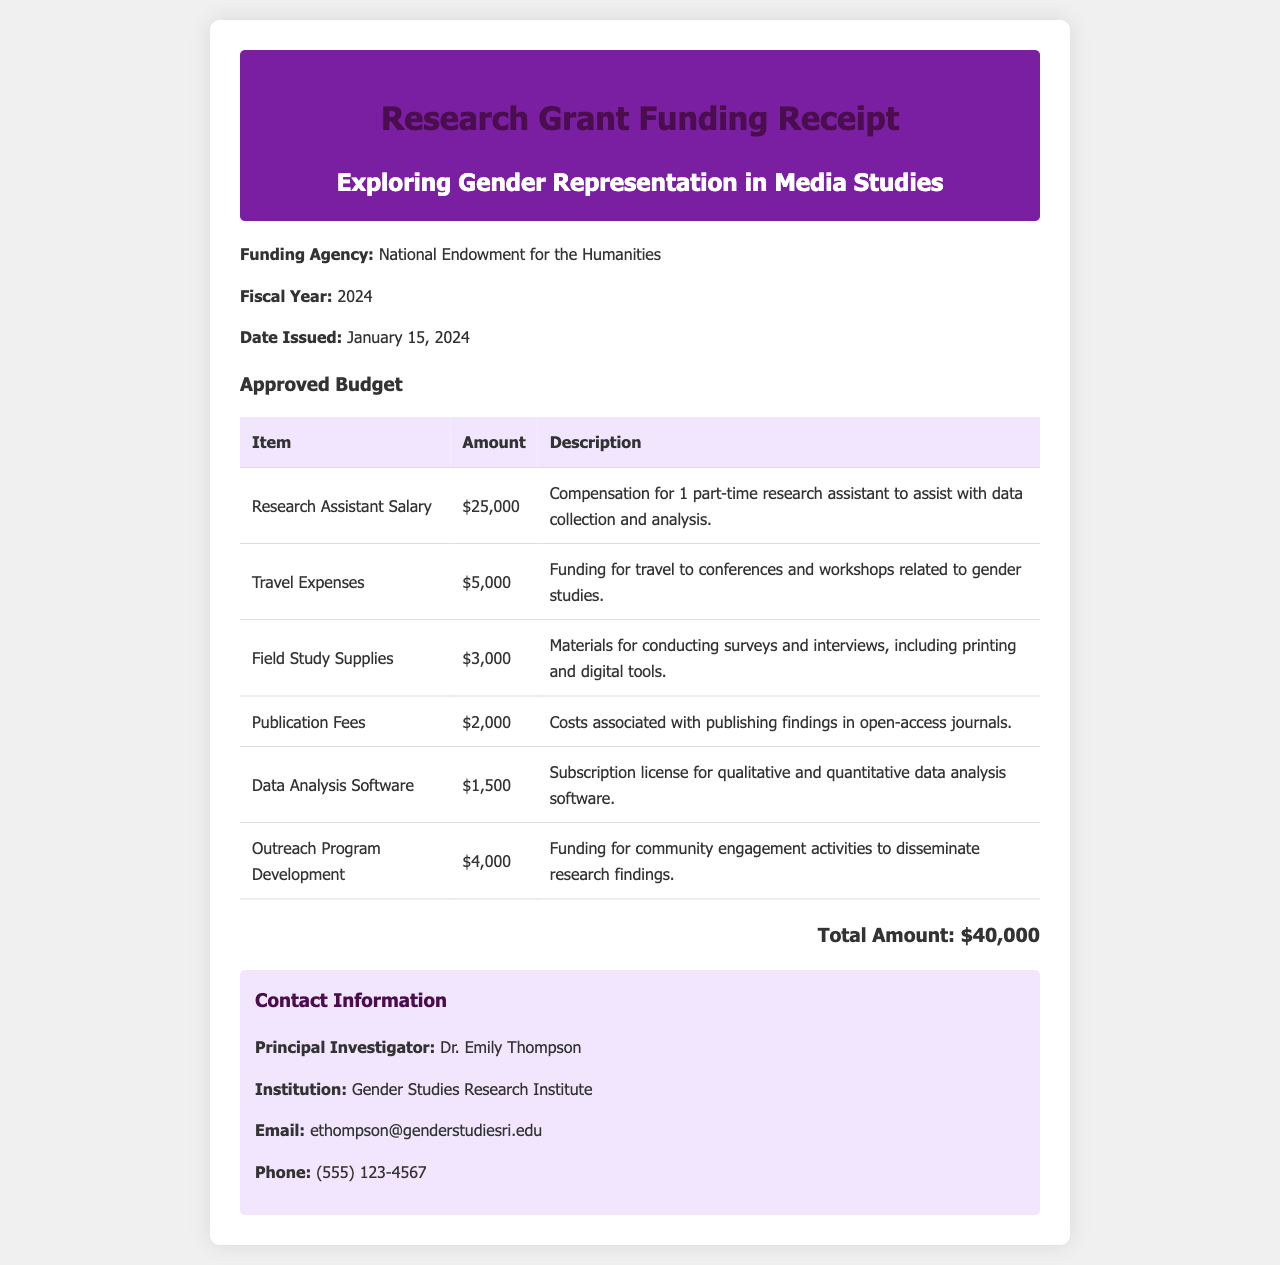What is the funding agency? The funding agency is mentioned directly in the document as the organization providing the grant.
Answer: National Endowment for the Humanities What is the date issued? The date issued is clearly stated in the document and pertains to when the receipt was created.
Answer: January 15, 2024 What is the total amount approved? The total amount is calculated based on the sum of all budget items listed in the document.
Answer: $40,000 Who is the principal investigator? The principal investigator's name is specifically mentioned in the contact information section of the document.
Answer: Dr. Emily Thompson How much is allocated for outreach program development? This amount is detailed in the approved budget section for specific projects related to the grant.
Answer: $4,000 What is the budget item for data analysis software? The document explicitly lists each item in the budget, which includes details about software expenses.
Answer: $1,500 What type of project is this funding for? The title of the research project is listed in the header of the receipt clearly indicating the subject matter.
Answer: Exploring Gender Representation in Media Studies What is the purpose of the travel expenses? The description for travel expenses in the budget explains the focus of these funds.
Answer: Related to gender studies What is included in field study supplies? The description under the field study supplies budget item specifies what the funding will be used for.
Answer: Surveys and interviews materials 